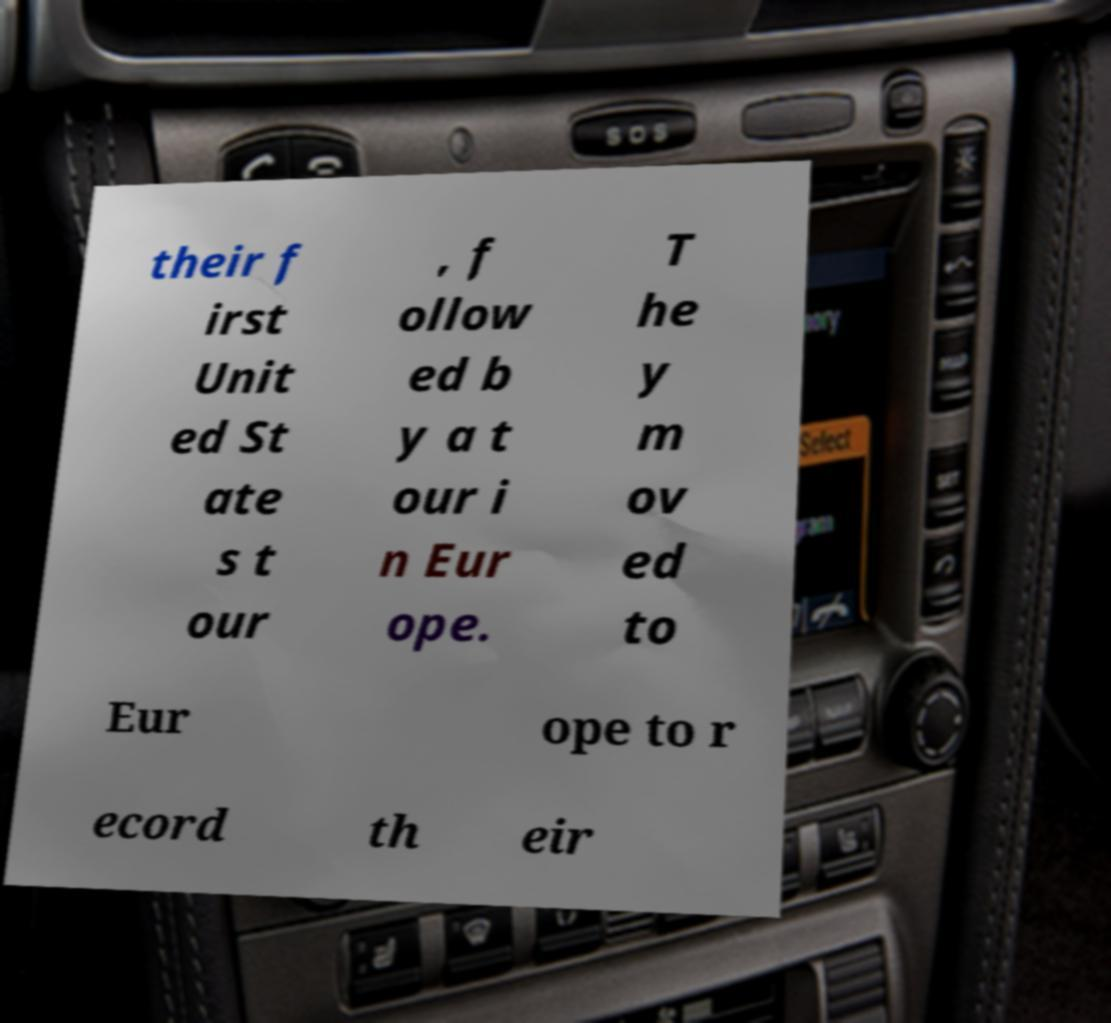Please read and relay the text visible in this image. What does it say? their f irst Unit ed St ate s t our , f ollow ed b y a t our i n Eur ope. T he y m ov ed to Eur ope to r ecord th eir 